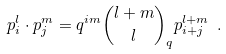Convert formula to latex. <formula><loc_0><loc_0><loc_500><loc_500>p _ { i } ^ { l } \cdot p _ { j } ^ { m } = q ^ { i m } { { l + m } \choose l } _ { q } p _ { i + j } ^ { l + m } \ .</formula> 